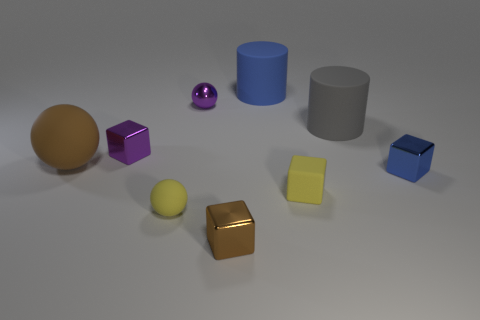Subtract 2 blocks. How many blocks are left? 2 Add 8 large rubber cylinders. How many large rubber cylinders are left? 10 Add 1 cyan metal cylinders. How many cyan metal cylinders exist? 1 Add 1 big green rubber things. How many objects exist? 10 Subtract all yellow cubes. How many cubes are left? 3 Subtract all shiny blocks. How many blocks are left? 1 Subtract 0 purple cylinders. How many objects are left? 9 Subtract all cylinders. How many objects are left? 7 Subtract all gray cylinders. Subtract all red cubes. How many cylinders are left? 1 Subtract all blue balls. How many blue cylinders are left? 1 